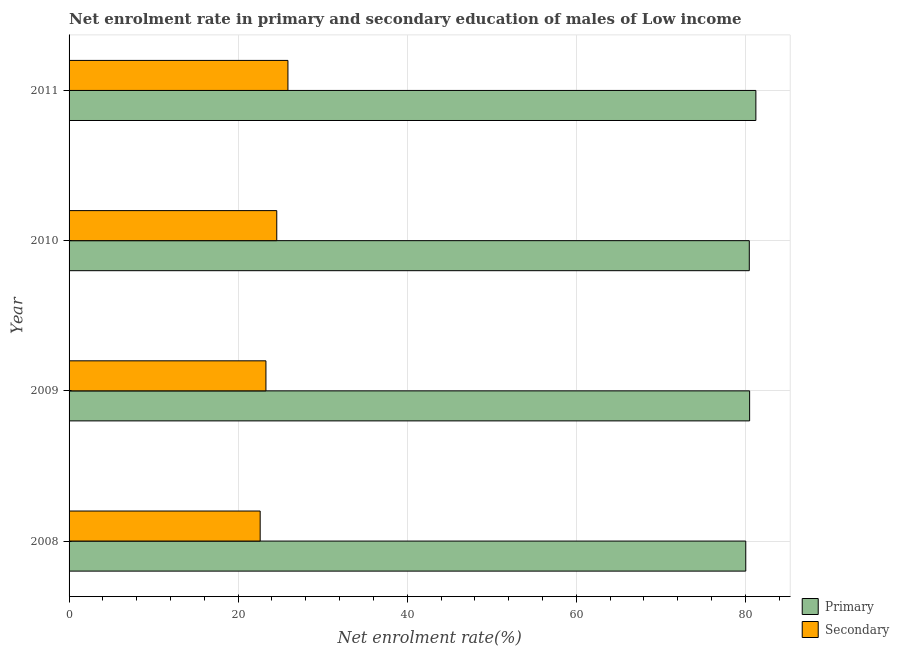How many different coloured bars are there?
Give a very brief answer. 2. Are the number of bars on each tick of the Y-axis equal?
Your answer should be compact. Yes. In how many cases, is the number of bars for a given year not equal to the number of legend labels?
Provide a short and direct response. 0. What is the enrollment rate in primary education in 2009?
Keep it short and to the point. 80.49. Across all years, what is the maximum enrollment rate in secondary education?
Your answer should be compact. 25.89. Across all years, what is the minimum enrollment rate in primary education?
Keep it short and to the point. 80.04. In which year was the enrollment rate in primary education minimum?
Offer a terse response. 2008. What is the total enrollment rate in secondary education in the graph?
Offer a very short reply. 96.34. What is the difference between the enrollment rate in secondary education in 2008 and that in 2011?
Offer a very short reply. -3.29. What is the difference between the enrollment rate in secondary education in 2009 and the enrollment rate in primary education in 2008?
Provide a succinct answer. -56.75. What is the average enrollment rate in secondary education per year?
Your response must be concise. 24.09. In the year 2009, what is the difference between the enrollment rate in primary education and enrollment rate in secondary education?
Offer a very short reply. 57.21. In how many years, is the enrollment rate in primary education greater than 56 %?
Your response must be concise. 4. What is the ratio of the enrollment rate in primary education in 2008 to that in 2009?
Your answer should be compact. 0.99. Is the difference between the enrollment rate in secondary education in 2009 and 2011 greater than the difference between the enrollment rate in primary education in 2009 and 2011?
Give a very brief answer. No. What is the difference between the highest and the second highest enrollment rate in secondary education?
Ensure brevity in your answer.  1.32. What is the difference between the highest and the lowest enrollment rate in primary education?
Offer a terse response. 1.19. In how many years, is the enrollment rate in secondary education greater than the average enrollment rate in secondary education taken over all years?
Your answer should be very brief. 2. Is the sum of the enrollment rate in secondary education in 2008 and 2009 greater than the maximum enrollment rate in primary education across all years?
Offer a terse response. No. What does the 1st bar from the top in 2008 represents?
Offer a terse response. Secondary. What does the 2nd bar from the bottom in 2010 represents?
Keep it short and to the point. Secondary. What is the difference between two consecutive major ticks on the X-axis?
Keep it short and to the point. 20. Are the values on the major ticks of X-axis written in scientific E-notation?
Your answer should be very brief. No. Where does the legend appear in the graph?
Ensure brevity in your answer.  Bottom right. How many legend labels are there?
Ensure brevity in your answer.  2. How are the legend labels stacked?
Give a very brief answer. Vertical. What is the title of the graph?
Provide a short and direct response. Net enrolment rate in primary and secondary education of males of Low income. Does "Researchers" appear as one of the legend labels in the graph?
Keep it short and to the point. No. What is the label or title of the X-axis?
Your answer should be very brief. Net enrolment rate(%). What is the Net enrolment rate(%) of Primary in 2008?
Your answer should be compact. 80.04. What is the Net enrolment rate(%) in Secondary in 2008?
Offer a terse response. 22.6. What is the Net enrolment rate(%) in Primary in 2009?
Offer a terse response. 80.49. What is the Net enrolment rate(%) of Secondary in 2009?
Offer a very short reply. 23.29. What is the Net enrolment rate(%) of Primary in 2010?
Give a very brief answer. 80.46. What is the Net enrolment rate(%) in Secondary in 2010?
Offer a very short reply. 24.57. What is the Net enrolment rate(%) in Primary in 2011?
Provide a succinct answer. 81.23. What is the Net enrolment rate(%) of Secondary in 2011?
Give a very brief answer. 25.89. Across all years, what is the maximum Net enrolment rate(%) in Primary?
Your answer should be compact. 81.23. Across all years, what is the maximum Net enrolment rate(%) of Secondary?
Provide a succinct answer. 25.89. Across all years, what is the minimum Net enrolment rate(%) of Primary?
Your answer should be very brief. 80.04. Across all years, what is the minimum Net enrolment rate(%) of Secondary?
Offer a terse response. 22.6. What is the total Net enrolment rate(%) in Primary in the graph?
Give a very brief answer. 322.22. What is the total Net enrolment rate(%) in Secondary in the graph?
Provide a short and direct response. 96.34. What is the difference between the Net enrolment rate(%) of Primary in 2008 and that in 2009?
Make the answer very short. -0.46. What is the difference between the Net enrolment rate(%) of Secondary in 2008 and that in 2009?
Your answer should be very brief. -0.68. What is the difference between the Net enrolment rate(%) of Primary in 2008 and that in 2010?
Offer a terse response. -0.42. What is the difference between the Net enrolment rate(%) in Secondary in 2008 and that in 2010?
Your answer should be compact. -1.96. What is the difference between the Net enrolment rate(%) of Primary in 2008 and that in 2011?
Provide a succinct answer. -1.19. What is the difference between the Net enrolment rate(%) in Secondary in 2008 and that in 2011?
Your response must be concise. -3.29. What is the difference between the Net enrolment rate(%) of Primary in 2009 and that in 2010?
Give a very brief answer. 0.04. What is the difference between the Net enrolment rate(%) of Secondary in 2009 and that in 2010?
Provide a short and direct response. -1.28. What is the difference between the Net enrolment rate(%) of Primary in 2009 and that in 2011?
Your answer should be very brief. -0.74. What is the difference between the Net enrolment rate(%) in Secondary in 2009 and that in 2011?
Keep it short and to the point. -2.6. What is the difference between the Net enrolment rate(%) of Primary in 2010 and that in 2011?
Ensure brevity in your answer.  -0.78. What is the difference between the Net enrolment rate(%) of Secondary in 2010 and that in 2011?
Make the answer very short. -1.32. What is the difference between the Net enrolment rate(%) in Primary in 2008 and the Net enrolment rate(%) in Secondary in 2009?
Your answer should be compact. 56.75. What is the difference between the Net enrolment rate(%) in Primary in 2008 and the Net enrolment rate(%) in Secondary in 2010?
Your answer should be very brief. 55.47. What is the difference between the Net enrolment rate(%) of Primary in 2008 and the Net enrolment rate(%) of Secondary in 2011?
Your response must be concise. 54.15. What is the difference between the Net enrolment rate(%) of Primary in 2009 and the Net enrolment rate(%) of Secondary in 2010?
Ensure brevity in your answer.  55.93. What is the difference between the Net enrolment rate(%) in Primary in 2009 and the Net enrolment rate(%) in Secondary in 2011?
Offer a very short reply. 54.61. What is the difference between the Net enrolment rate(%) in Primary in 2010 and the Net enrolment rate(%) in Secondary in 2011?
Keep it short and to the point. 54.57. What is the average Net enrolment rate(%) in Primary per year?
Keep it short and to the point. 80.56. What is the average Net enrolment rate(%) in Secondary per year?
Keep it short and to the point. 24.09. In the year 2008, what is the difference between the Net enrolment rate(%) in Primary and Net enrolment rate(%) in Secondary?
Your response must be concise. 57.44. In the year 2009, what is the difference between the Net enrolment rate(%) in Primary and Net enrolment rate(%) in Secondary?
Give a very brief answer. 57.21. In the year 2010, what is the difference between the Net enrolment rate(%) of Primary and Net enrolment rate(%) of Secondary?
Ensure brevity in your answer.  55.89. In the year 2011, what is the difference between the Net enrolment rate(%) of Primary and Net enrolment rate(%) of Secondary?
Your answer should be compact. 55.35. What is the ratio of the Net enrolment rate(%) in Primary in 2008 to that in 2009?
Keep it short and to the point. 0.99. What is the ratio of the Net enrolment rate(%) in Secondary in 2008 to that in 2009?
Provide a short and direct response. 0.97. What is the ratio of the Net enrolment rate(%) in Secondary in 2008 to that in 2010?
Provide a short and direct response. 0.92. What is the ratio of the Net enrolment rate(%) in Secondary in 2008 to that in 2011?
Provide a short and direct response. 0.87. What is the ratio of the Net enrolment rate(%) of Primary in 2009 to that in 2010?
Ensure brevity in your answer.  1. What is the ratio of the Net enrolment rate(%) of Secondary in 2009 to that in 2010?
Offer a very short reply. 0.95. What is the ratio of the Net enrolment rate(%) of Primary in 2009 to that in 2011?
Give a very brief answer. 0.99. What is the ratio of the Net enrolment rate(%) in Secondary in 2009 to that in 2011?
Ensure brevity in your answer.  0.9. What is the ratio of the Net enrolment rate(%) in Primary in 2010 to that in 2011?
Provide a succinct answer. 0.99. What is the ratio of the Net enrolment rate(%) in Secondary in 2010 to that in 2011?
Offer a very short reply. 0.95. What is the difference between the highest and the second highest Net enrolment rate(%) of Primary?
Your response must be concise. 0.74. What is the difference between the highest and the second highest Net enrolment rate(%) of Secondary?
Provide a succinct answer. 1.32. What is the difference between the highest and the lowest Net enrolment rate(%) in Primary?
Ensure brevity in your answer.  1.19. What is the difference between the highest and the lowest Net enrolment rate(%) of Secondary?
Your response must be concise. 3.29. 